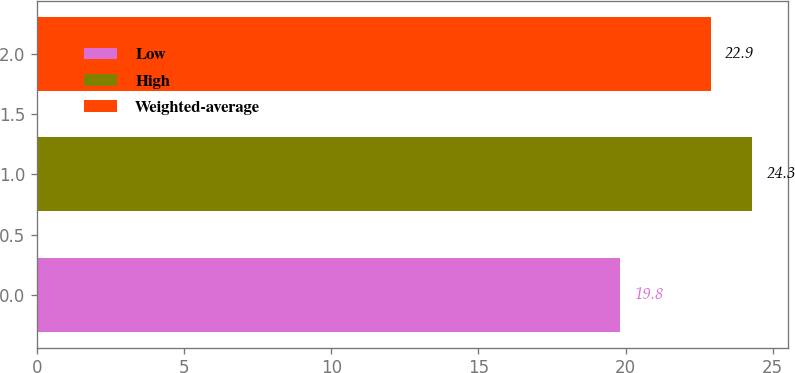Convert chart. <chart><loc_0><loc_0><loc_500><loc_500><bar_chart><fcel>Low<fcel>High<fcel>Weighted-average<nl><fcel>19.8<fcel>24.3<fcel>22.9<nl></chart> 